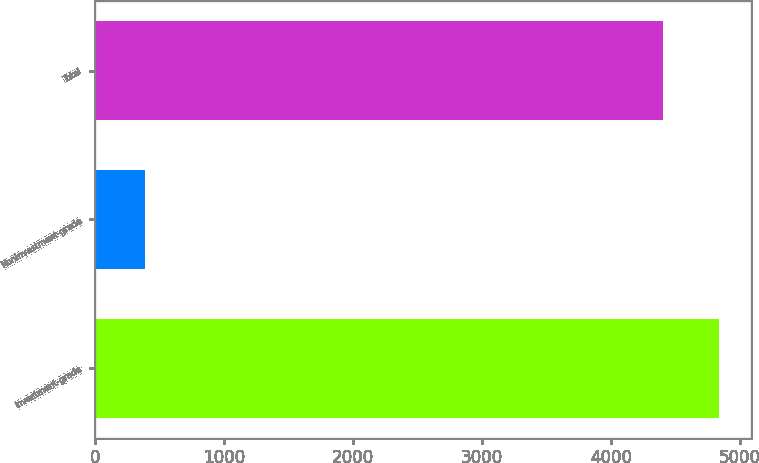Convert chart. <chart><loc_0><loc_0><loc_500><loc_500><bar_chart><fcel>Investment-grade<fcel>Noninvestment-grade<fcel>Total<nl><fcel>4840<fcel>386<fcel>4400<nl></chart> 